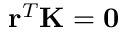Convert formula to latex. <formula><loc_0><loc_0><loc_500><loc_500>r ^ { T } K = 0</formula> 